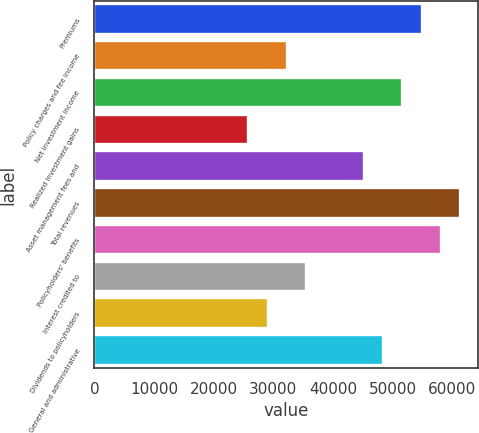Convert chart to OTSL. <chart><loc_0><loc_0><loc_500><loc_500><bar_chart><fcel>Premiums<fcel>Policy charges and fee income<fcel>Net investment income<fcel>Realized investment gains<fcel>Asset management fees and<fcel>Total revenues<fcel>Policyholders' benefits<fcel>Interest credited to<fcel>Dividends to policyholders<fcel>General and administrative<nl><fcel>54855<fcel>32268<fcel>51628.2<fcel>25814.6<fcel>45174.8<fcel>61308.4<fcel>58081.7<fcel>35494.7<fcel>29041.3<fcel>48401.5<nl></chart> 